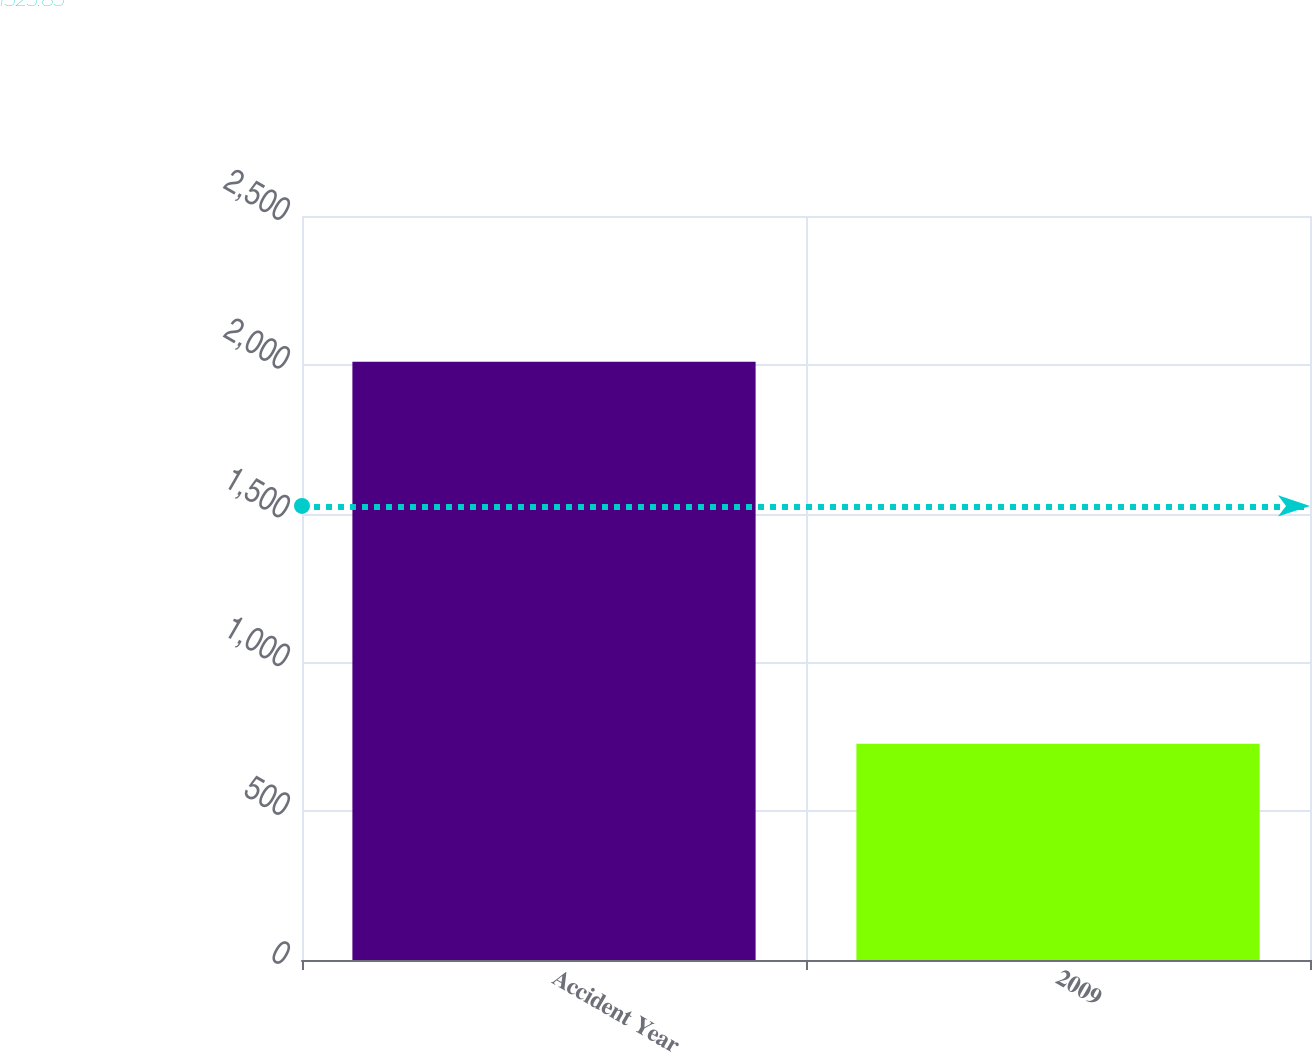Convert chart to OTSL. <chart><loc_0><loc_0><loc_500><loc_500><bar_chart><fcel>Accident Year<fcel>2009<nl><fcel>2010<fcel>727<nl></chart> 